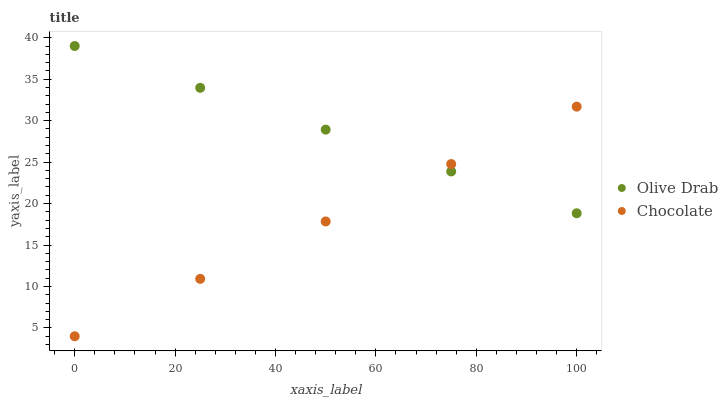Does Chocolate have the minimum area under the curve?
Answer yes or no. Yes. Does Olive Drab have the maximum area under the curve?
Answer yes or no. Yes. Does Chocolate have the maximum area under the curve?
Answer yes or no. No. Is Chocolate the smoothest?
Answer yes or no. Yes. Is Olive Drab the roughest?
Answer yes or no. Yes. Is Chocolate the roughest?
Answer yes or no. No. Does Chocolate have the lowest value?
Answer yes or no. Yes. Does Olive Drab have the highest value?
Answer yes or no. Yes. Does Chocolate have the highest value?
Answer yes or no. No. Does Olive Drab intersect Chocolate?
Answer yes or no. Yes. Is Olive Drab less than Chocolate?
Answer yes or no. No. Is Olive Drab greater than Chocolate?
Answer yes or no. No. 